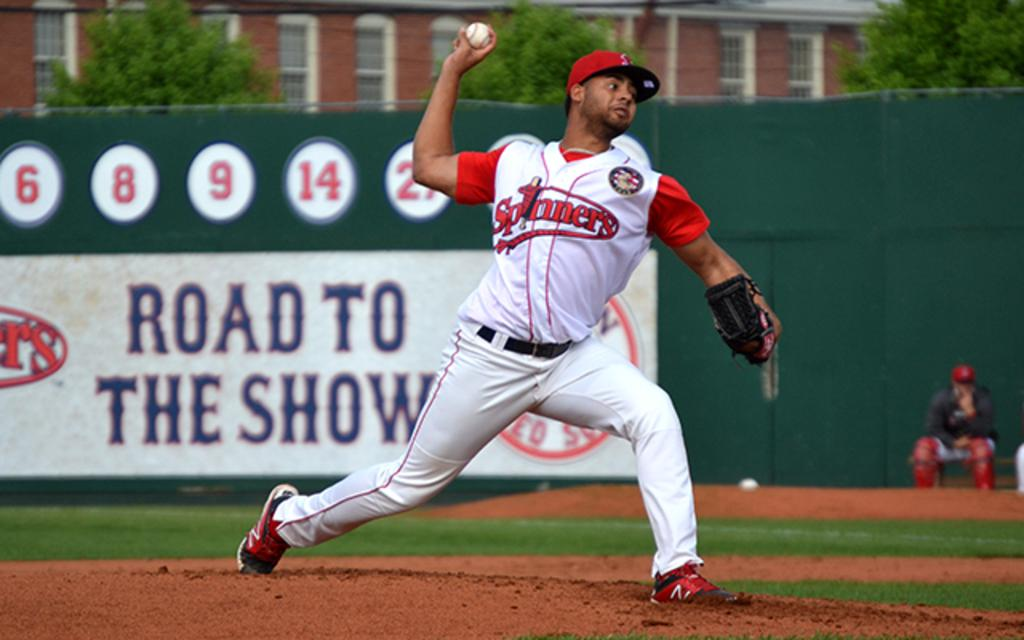<image>
Give a short and clear explanation of the subsequent image. spinners pitcher throwing the ball in front of sign that has road to the show on it 